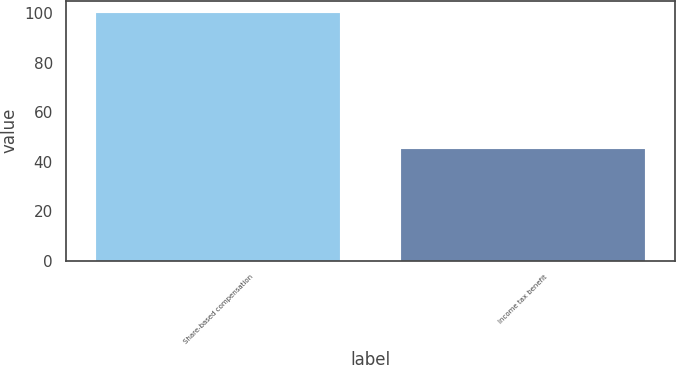Convert chart to OTSL. <chart><loc_0><loc_0><loc_500><loc_500><bar_chart><fcel>Share-based compensation<fcel>Income tax benefit<nl><fcel>100<fcel>45<nl></chart> 